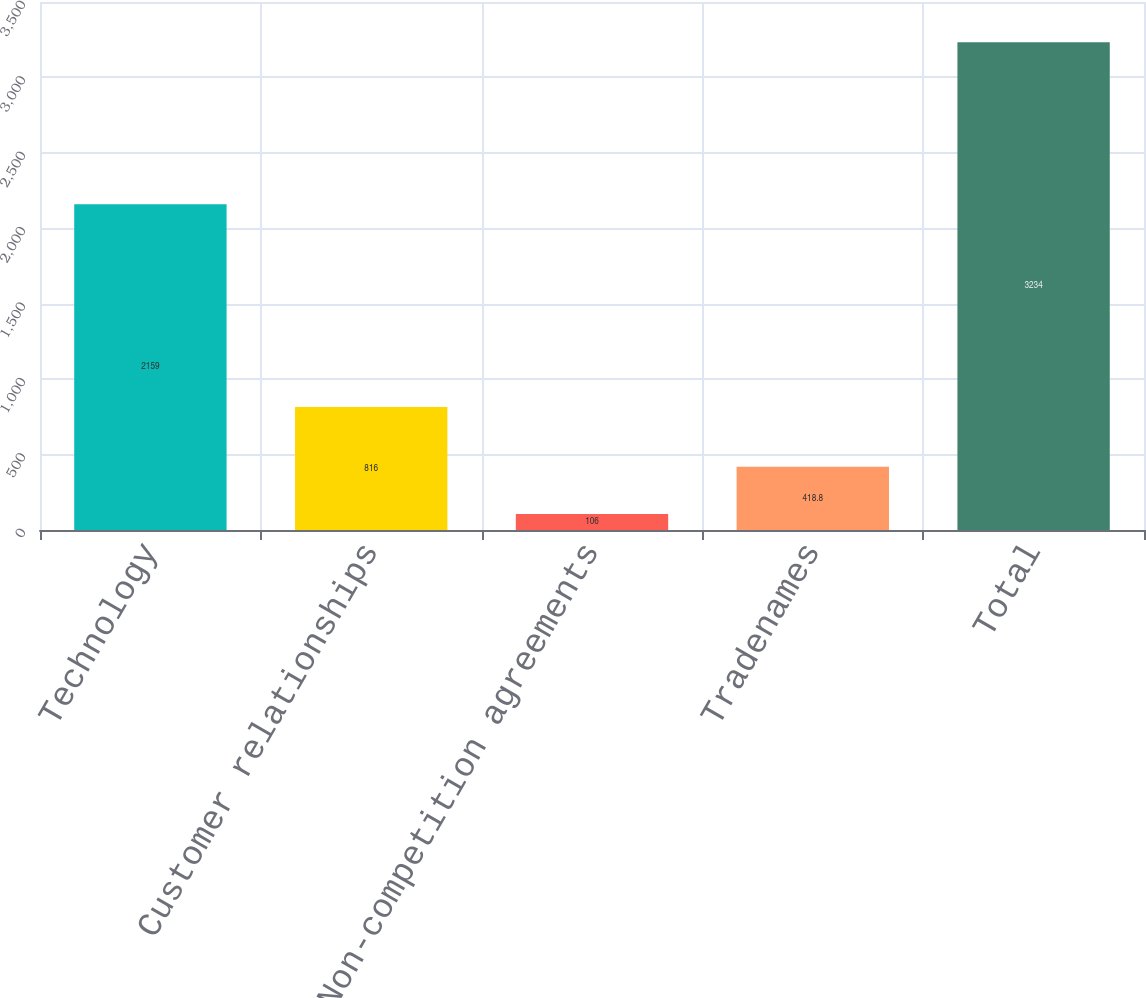Convert chart to OTSL. <chart><loc_0><loc_0><loc_500><loc_500><bar_chart><fcel>Technology<fcel>Customer relationships<fcel>Non-competition agreements<fcel>Tradenames<fcel>Total<nl><fcel>2159<fcel>816<fcel>106<fcel>418.8<fcel>3234<nl></chart> 